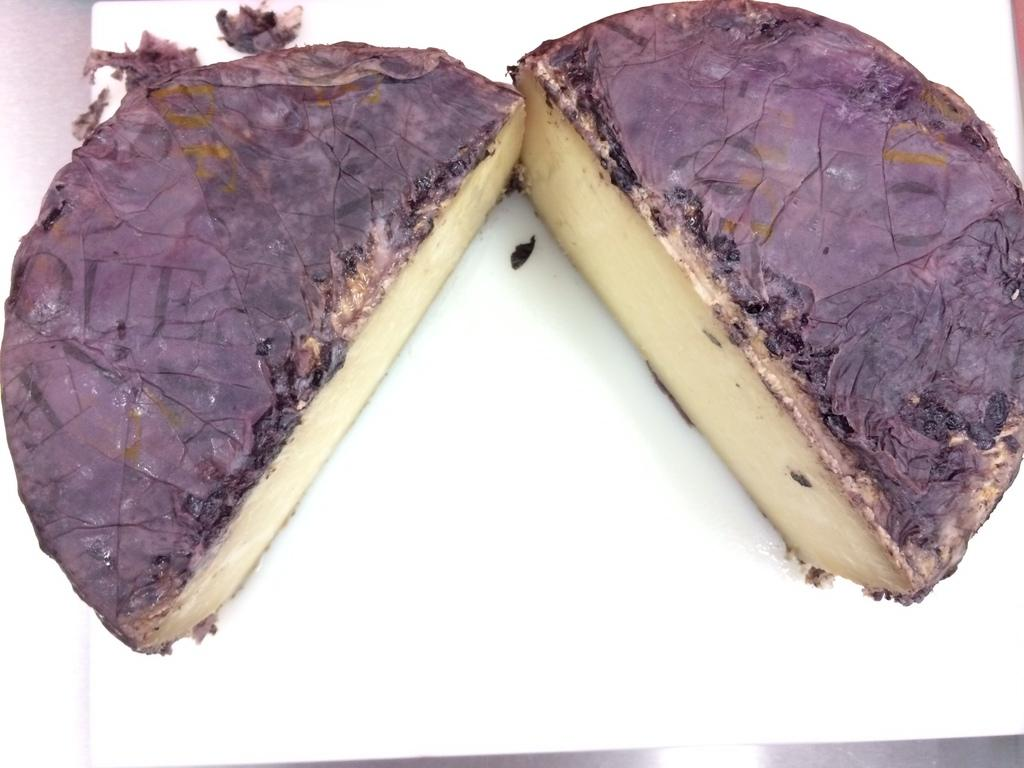What type of dessert is visible in the image? There is a cheese cake in the image. On what surface is the cheese cake placed? The cheese cake is placed on a white surface. What type of footwear is visible in the image? There is no footwear present in the image; it only features a cheese cake on a white surface. 